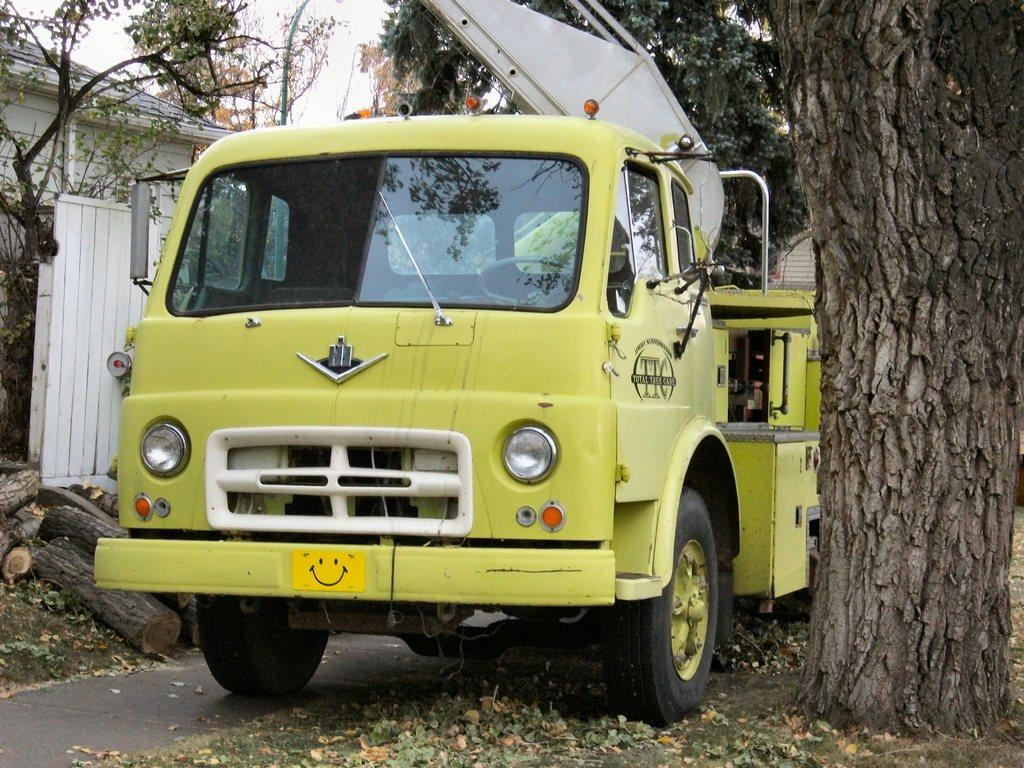What is the main subject in the center of the image? There is a vehicle in the center of the image. What is the color of the vehicle? The vehicle is green in color. What can be seen in the background of the image? In the background of the image, there is a sky, clouds, trees, and buildings visible. What additional detail can be observed in the background? Dry leaves are visible in the background of the image. What is the level of destruction caused by the aftermath of the explosion in the image? There is no explosion or destruction present in the image; it features a green vehicle with a background of sky, clouds, trees, buildings, and dry leaves. 